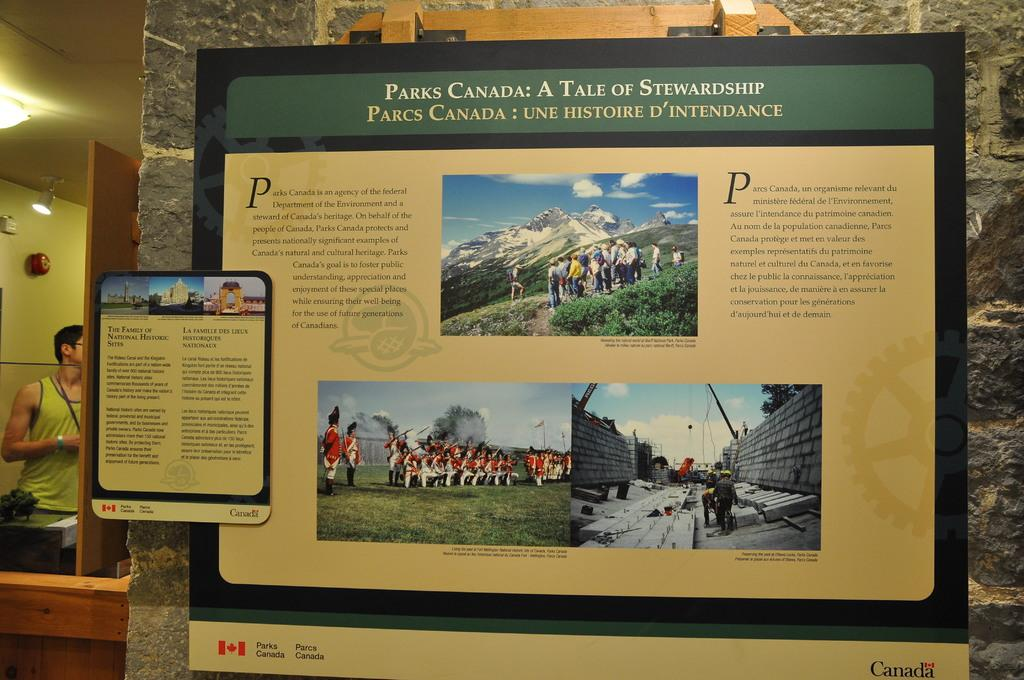<image>
Provide a brief description of the given image. Sign showing people near a mountain and the words "PARKS CANADA" on top. 